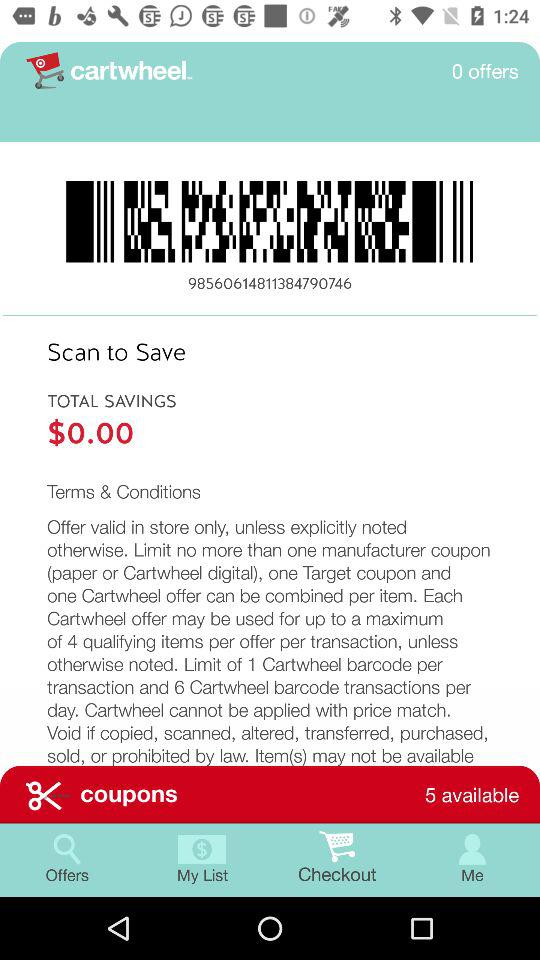How many coupons are available? There are 5 coupons. 